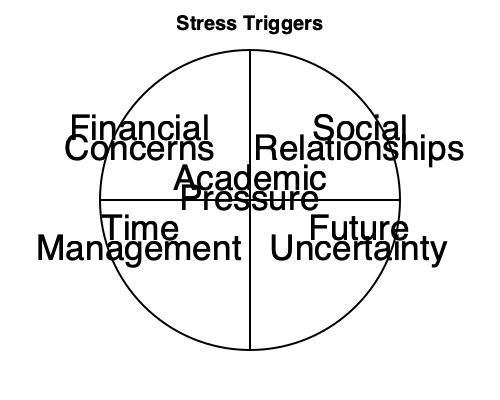Based on the mind map of stress triggers for college students, which category would likely include concerns about maintaining a high GPA, managing coursework load, and meeting academic expectations? To answer this question, let's analyze the mind map of stress triggers for college students:

1. The mind map shows five main categories of stress triggers:
   - Academic Pressure (center)
   - Financial Concerns (top left)
   - Social Relationships (top right)
   - Time Management (bottom left)
   - Future Uncertainty (bottom right)

2. Consider the nature of the concerns mentioned in the question:
   - Maintaining a high GPA
   - Managing coursework load
   - Meeting academic expectations

3. These concerns are directly related to academic performance and the pressure associated with succeeding in college studies.

4. Among the categories presented in the mind map, "Academic Pressure" is the most relevant and appropriate category for these concerns.

5. The other categories, while potentially related, do not directly address the specific academic-focused stressors mentioned in the question:
   - Financial Concerns are about money-related issues
   - Social Relationships pertain to interpersonal interactions
   - Time Management, while related to coursework, is more about scheduling and organization
   - Future Uncertainty deals with concerns about post-graduation life

Therefore, the category that would most likely include concerns about maintaining a high GPA, managing coursework load, and meeting academic expectations is Academic Pressure.
Answer: Academic Pressure 